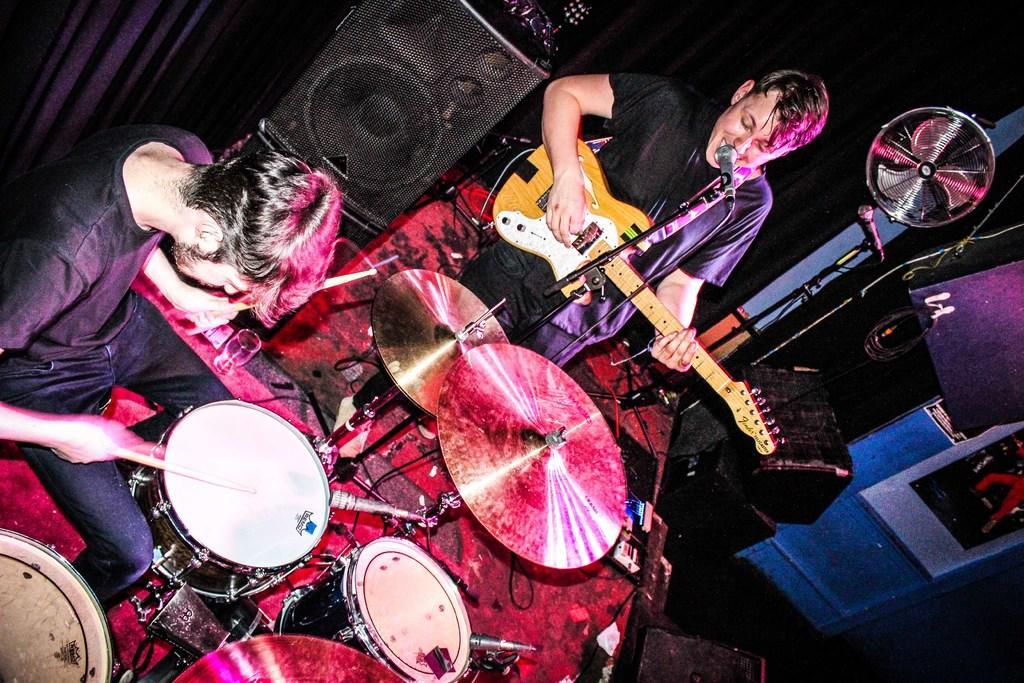How would you summarize this image in a sentence or two? In the image we can see two persons. On the left we can see person holding sticks. In the center we can see the person holding guitar,in front of him we can see microphone. Around them we can see some musical instruments and speaker and curtain. 